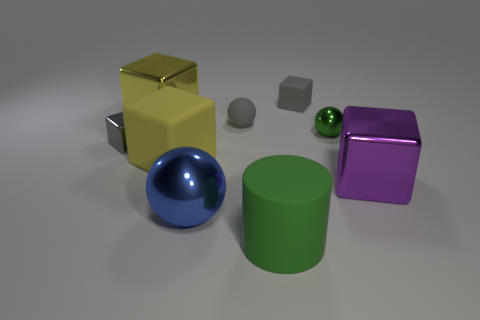Subtract all shiny spheres. How many spheres are left? 1 Subtract all purple cylinders. How many yellow blocks are left? 2 Add 1 tiny gray rubber blocks. How many objects exist? 10 Subtract all purple blocks. How many blocks are left? 4 Subtract 2 blocks. How many blocks are left? 3 Subtract all balls. How many objects are left? 6 Subtract all purple blocks. Subtract all matte blocks. How many objects are left? 6 Add 4 blue metallic objects. How many blue metallic objects are left? 5 Add 1 purple blocks. How many purple blocks exist? 2 Subtract 0 yellow cylinders. How many objects are left? 9 